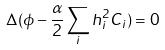<formula> <loc_0><loc_0><loc_500><loc_500>\Delta ( \phi - \frac { \alpha } { 2 } \sum _ { i } h _ { i } ^ { 2 } C _ { i } ) = 0</formula> 